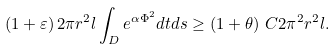Convert formula to latex. <formula><loc_0><loc_0><loc_500><loc_500>\left ( { 1 + \varepsilon } \right ) 2 \pi r ^ { 2 } l \int _ { D } { e ^ { \alpha \Phi ^ { 2 } } d t d s \geq } \, \left ( { 1 + \theta } \right ) \, C 2 \pi ^ { 2 } r ^ { 2 } l .</formula> 